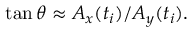<formula> <loc_0><loc_0><loc_500><loc_500>\tan \theta \approx A _ { x } ( t _ { i } ) / A _ { y } ( t _ { i } ) .</formula> 